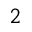<formula> <loc_0><loc_0><loc_500><loc_500>_ { 2 }</formula> 